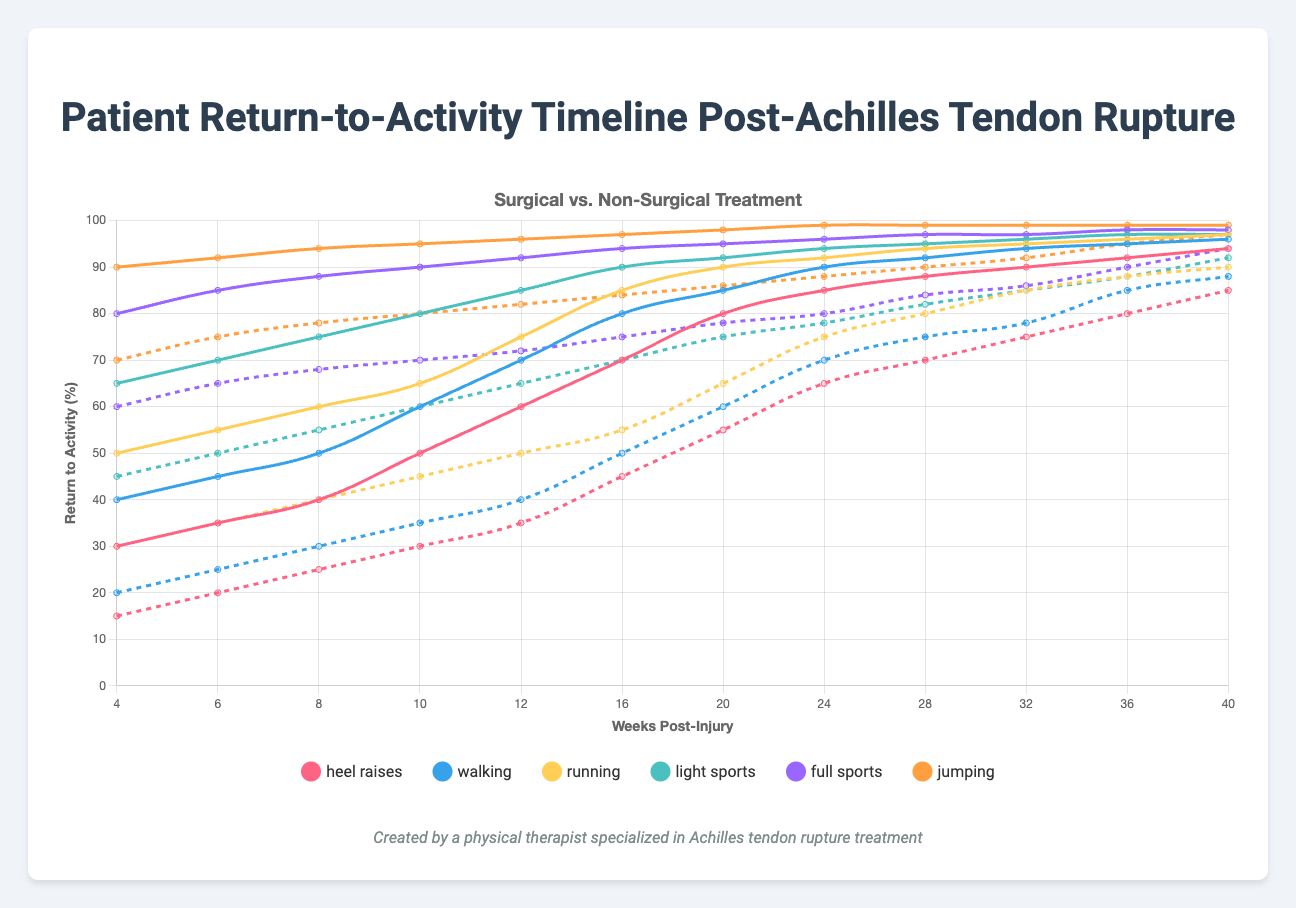Which treatment method allows for running earlier, surgical or non-surgical? Compare the 'running' data points for both treatments across the weeks. The surgical method consistently shows higher return-to-activity percentages, indicating an earlier return to running.
Answer: Surgical At 16 weeks post-injury, what is the difference in return-to-activity percentages for heel raises between surgical and non-surgical treatments? At 16 weeks, the return-to-activity percentage for heel raises is 70% for surgical and 45% for non-surgical. The difference is 70% - 45% = 25%.
Answer: 25% Between 24 and 28 weeks post-injury, which activity shows the smallest increase for non-surgical treatment? Evaluate the change in return-to-activity percentages for each activity between 24 and 28 weeks for non-surgical treatment. The smallest increase is for light sports (78% to 82%), which is 4%.
Answer: Light sports By 40 weeks post-injury, how much higher is the percentage for jumping activities in surgical treatment compared to non-surgical treatment? At 40 weeks, the surgical treatment shows a 99% return-to-activity percentage for jumping, while the non-surgical treatment shows 97%. The difference is 99% - 97% = 2%.
Answer: 2% Which activity reaches a 50% return-to-activity first for the non-surgical treatment? Identify the activity that first reaches or exceeds 50% in the non-surgical treatment data. At 8 weeks, walking reaches 50%.
Answer: Walking What is the average return-to-activity percentage for light sports for non-surgical treatment between 12 and 36 weeks post-injury? Calculate the average percentage for light sports across data points at 12, 16, 20, 24, 28, 32, and 36 weeks. (65 + 70 + 75 + 78 + 82 + 85 + 88) / 7 = 77.57%.
Answer: 77.57% Which treatment approach shows a steadier improvement across all activities at 20 weeks post-injury? Compare the improvement percentages from start to 20 weeks for both treatments across all activities. Surgical treatment shows a more consistent increase across all activities.
Answer: Surgical At 24 weeks post-injury, what is the percentage difference for full sports between surgical and non-surgical treatments? At 24 weeks, the percentage for full sports is 96% for surgical and 80% for non-surgical. The difference is 96% - 80% = 16%.
Answer: 16% Which activity reaches a 90% return-to-activity the latest for non-surgical treatment? Determine the latest data point where an activity for non-surgical treatment reaches or exceeds 90%. Running reaches 90% at 40 weeks.
Answer: Running How does the return-to-activity for walking compare at the 10-week and 20-week marks for non-surgical treatment? At 10 weeks, walking is at 35%. At 20 weeks, it is at 60%. The percentage increase is 60% - 35% = 25%.
Answer: Increase by 25% 